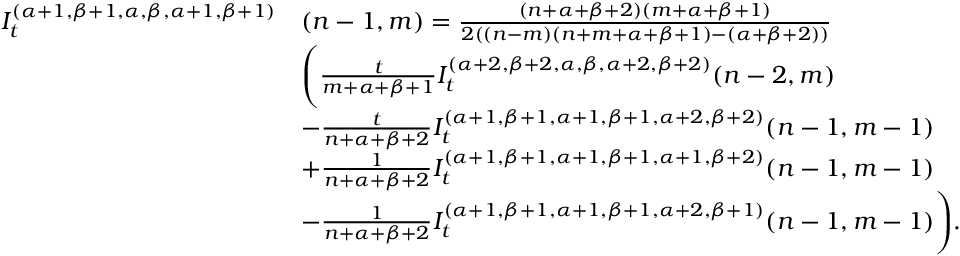Convert formula to latex. <formula><loc_0><loc_0><loc_500><loc_500>\begin{array} { r l } { I _ { t } ^ { ( \alpha + 1 , \beta + 1 , \alpha , \beta , \alpha + 1 , \beta + 1 ) } } & { ( n - 1 , m ) = \frac { ( n + \alpha + \beta + 2 ) ( m + \alpha + \beta + 1 ) } { 2 ( ( n - m ) ( n + m + \alpha + \beta + 1 ) - ( \alpha + \beta + 2 ) ) } } \\ & { \left ( \frac { t } { m + \alpha + \beta + 1 } I _ { t } ^ { ( \alpha + 2 , \beta + 2 , \alpha , \beta , \alpha + 2 , \beta + 2 ) } { ( n - 2 , m ) } } \\ & { - \frac { t } { n + \alpha + \beta + 2 } I _ { t } ^ { ( \alpha + 1 , \beta + 1 , \alpha + 1 , \beta + 1 , \alpha + 2 , \beta + 2 ) } { ( n - 1 , m - 1 ) } } \\ & { + \frac { 1 } { { n } + \alpha + \beta + 2 } I _ { t } ^ { ( \alpha + 1 , \beta + 1 , \alpha + 1 , \beta + 1 , \alpha + 1 , \beta + 2 ) } { ( n - 1 , m - 1 ) } } \\ & { { - } \frac { 1 } { n + \alpha + \beta + 2 } I _ { t } ^ { ( \alpha + 1 , \beta + 1 , \alpha + 1 , \beta + 1 , \alpha + 2 , \beta + 1 ) } { ( n - 1 , m - 1 ) } \right ) . } \end{array}</formula> 